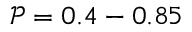<formula> <loc_0><loc_0><loc_500><loc_500>\mathcal { P } = 0 . 4 - 0 . 8 5</formula> 